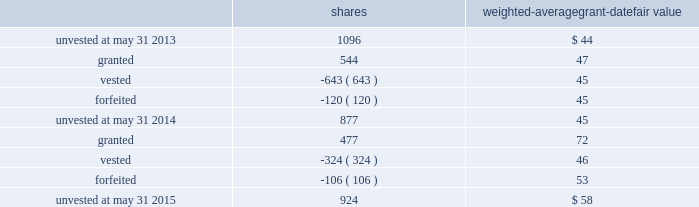The performance units granted to certain executives in fiscal 2014 were based on a one-year performance period .
After the compensation committee certified the performance results , 25% ( 25 % ) of the performance units converted to unrestricted shares .
The remaining 75% ( 75 % ) converted to restricted shares that vest in equal installments on each of the first three anniversaries of the conversion date .
The performance units granted to certain executives during fiscal 2015 were based on a three-year performance period .
After the compensation committee certifies the performance results for the three-year period , performance units earned will convert into unrestricted common stock .
The compensation committee may set a range of possible performance-based outcomes for performance units .
Depending on the achievement of the performance measures , the grantee may earn up to 200% ( 200 % ) of the target number of shares .
For awards with only performance conditions , we recognize compensation expense over the performance period using the grant date fair value of the award , which is based on the number of shares expected to be earned according to the level of achievement of performance goals .
If the number of shares expected to be earned were to change at any time during the performance period , we would make a cumulative adjustment to share-based compensation expense based on the revised number of shares expected to be earned .
During fiscal 2015 , certain executives were granted performance units that we refer to as leveraged performance units , or lpus .
Lpus contain a market condition based on our relative stock price growth over a three-year performance period .
The lpus contain a minimum threshold performance which , if not met , would result in no payout .
The lpus also contain a maximum award opportunity set as a fixed dollar and fixed number of shares .
After the three-year performance period , one-third of any earned units converts to unrestricted common stock .
The remaining two-thirds convert to restricted stock that will vest in equal installments on each of the first two anniversaries of the conversion date .
We recognize share-based compensation expense based on the grant date fair value of the lpus , as determined by use of a monte carlo model , on a straight-line basis over the requisite service period for each separately vesting portion of the lpu award .
Total shareholder return units before fiscal 2015 , certain of our executives were granted total shareholder return ( 201ctsr 201d ) units , which are performance-based restricted stock units that are earned based on our total shareholder return over a three-year performance period compared to companies in the s&p 500 .
Once the performance results are certified , tsr units convert into unrestricted common stock .
Depending on our performance , the grantee may earn up to 200% ( 200 % ) of the target number of shares .
The target number of tsr units for each executive is set by the compensation committee .
We recognize share-based compensation expense based on the grant date fair value of the tsr units , as determined by use of a monte carlo model , on a straight-line basis over the vesting period .
The table summarizes the changes in unvested share-based awards for the years ended may 31 , 2015 and 2014 ( shares in thousands ) : shares weighted-average grant-date fair value .
Global payments inc .
| 2015 form 10-k annual report 2013 81 .
What is the net change in the balance of unvested shares from 2013 to 2015? 
Computations: (924 - 1096)
Answer: -172.0. 